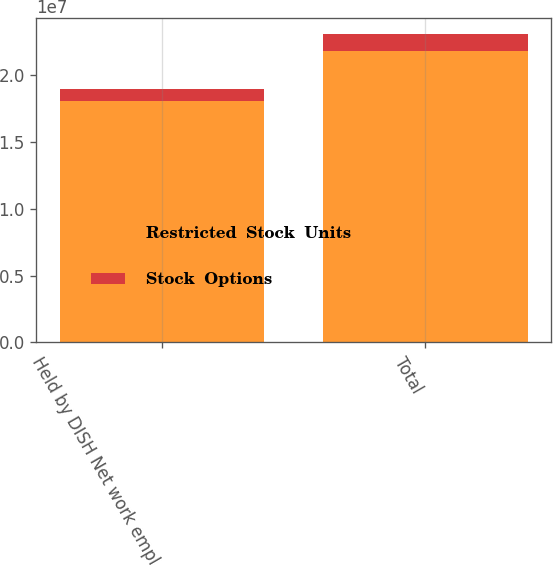Convert chart to OTSL. <chart><loc_0><loc_0><loc_500><loc_500><stacked_bar_chart><ecel><fcel>Held by DISH Net work empl<fcel>Total<nl><fcel>Restricted  Stock  Units<fcel>1.80942e+07<fcel>2.18617e+07<nl><fcel>Stock  Options<fcel>857719<fcel>1.24628e+06<nl></chart> 